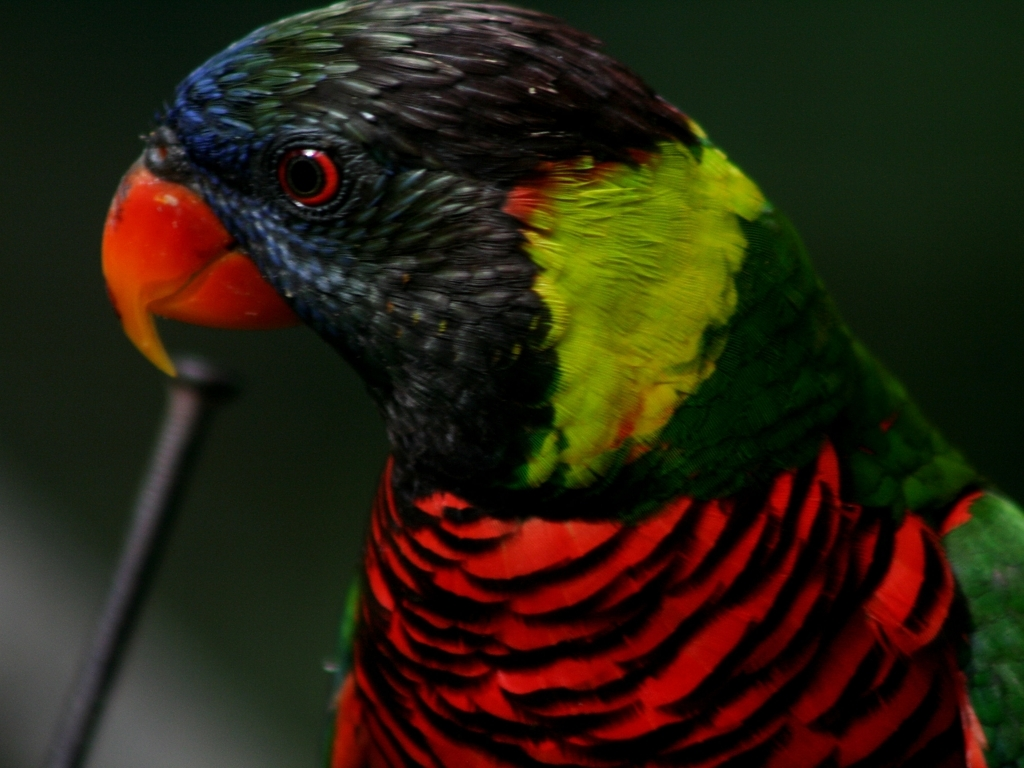How would one care for a parrot like this if they wanted it as a pet? Caring for a Rainbow Lorikeet involves providing a spacious cage, a varied diet rich in fruit, vegetables, and specialized nectar, regular social interaction, and mental stimulation through toys and puzzles. Additionally, it's important to ensure they get enough exercise and supervised out-of-cage time as they are quite active and sociable birds. 